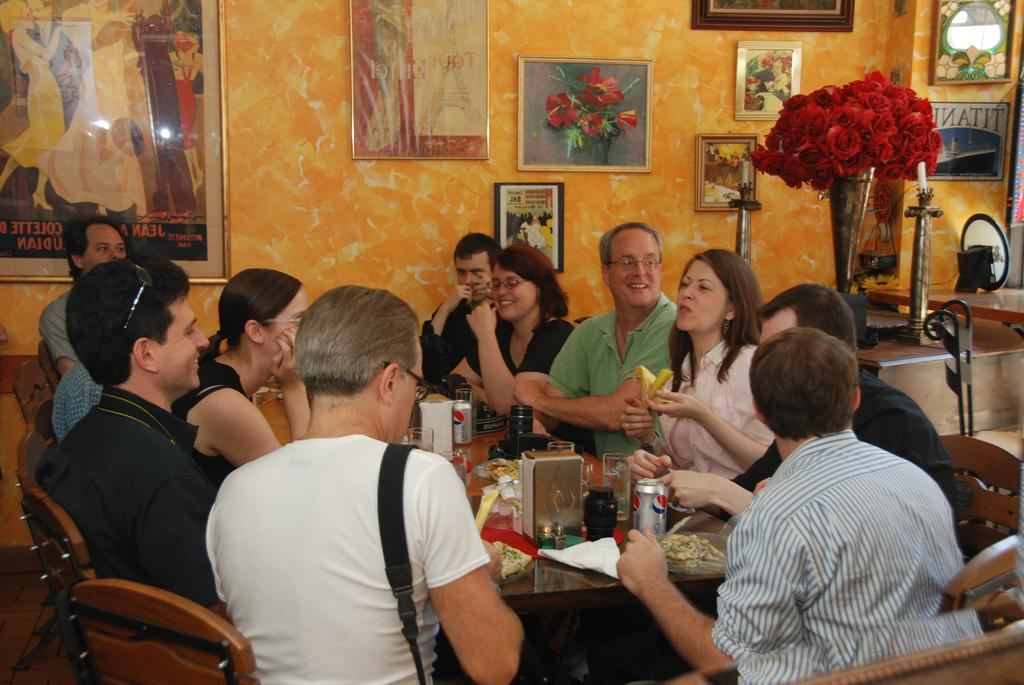What are the people in the image doing? The people in the image are sitting around a dining table. What can be seen in the image besides the people at the table? There are red flowers in the image. What is on the wall in the image? There are photo frames on the wall. What type of toys can be seen on the table in the image? There are no toys present on the table in the image. What team is playing in the background of the image? There is no team playing in the image; it features people sitting around a dining table with red flowers and photo frames on the wall. 